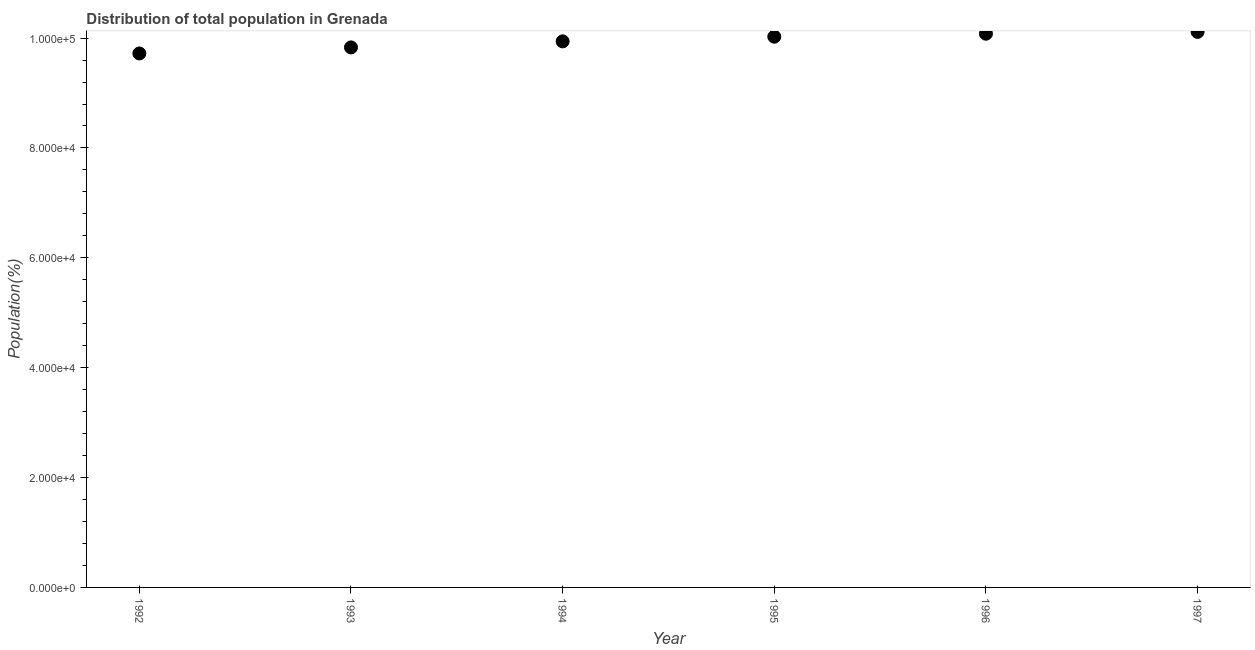What is the population in 1996?
Offer a very short reply. 1.01e+05. Across all years, what is the maximum population?
Your answer should be compact. 1.01e+05. Across all years, what is the minimum population?
Provide a short and direct response. 9.72e+04. In which year was the population minimum?
Keep it short and to the point. 1992. What is the sum of the population?
Provide a short and direct response. 5.97e+05. What is the difference between the population in 1992 and 1996?
Ensure brevity in your answer.  -3595. What is the average population per year?
Provide a succinct answer. 9.95e+04. What is the median population?
Your answer should be very brief. 9.98e+04. Do a majority of the years between 1997 and 1993 (inclusive) have population greater than 36000 %?
Offer a very short reply. Yes. What is the ratio of the population in 1993 to that in 1996?
Provide a succinct answer. 0.98. What is the difference between the highest and the second highest population?
Your response must be concise. 329. Is the sum of the population in 1993 and 1996 greater than the maximum population across all years?
Your answer should be compact. Yes. What is the difference between the highest and the lowest population?
Provide a short and direct response. 3924. Does the population monotonically increase over the years?
Offer a very short reply. Yes. How many dotlines are there?
Your answer should be very brief. 1. Does the graph contain any zero values?
Offer a terse response. No. What is the title of the graph?
Offer a terse response. Distribution of total population in Grenada . What is the label or title of the X-axis?
Make the answer very short. Year. What is the label or title of the Y-axis?
Make the answer very short. Population(%). What is the Population(%) in 1992?
Your answer should be compact. 9.72e+04. What is the Population(%) in 1993?
Offer a terse response. 9.83e+04. What is the Population(%) in 1994?
Offer a very short reply. 9.94e+04. What is the Population(%) in 1995?
Offer a terse response. 1.00e+05. What is the Population(%) in 1996?
Your response must be concise. 1.01e+05. What is the Population(%) in 1997?
Make the answer very short. 1.01e+05. What is the difference between the Population(%) in 1992 and 1993?
Offer a very short reply. -1101. What is the difference between the Population(%) in 1992 and 1994?
Give a very brief answer. -2202. What is the difference between the Population(%) in 1992 and 1995?
Provide a succinct answer. -3052. What is the difference between the Population(%) in 1992 and 1996?
Your answer should be compact. -3595. What is the difference between the Population(%) in 1992 and 1997?
Your response must be concise. -3924. What is the difference between the Population(%) in 1993 and 1994?
Your answer should be very brief. -1101. What is the difference between the Population(%) in 1993 and 1995?
Keep it short and to the point. -1951. What is the difference between the Population(%) in 1993 and 1996?
Your response must be concise. -2494. What is the difference between the Population(%) in 1993 and 1997?
Keep it short and to the point. -2823. What is the difference between the Population(%) in 1994 and 1995?
Your response must be concise. -850. What is the difference between the Population(%) in 1994 and 1996?
Provide a succinct answer. -1393. What is the difference between the Population(%) in 1994 and 1997?
Offer a terse response. -1722. What is the difference between the Population(%) in 1995 and 1996?
Your response must be concise. -543. What is the difference between the Population(%) in 1995 and 1997?
Your answer should be compact. -872. What is the difference between the Population(%) in 1996 and 1997?
Offer a terse response. -329. What is the ratio of the Population(%) in 1992 to that in 1994?
Offer a very short reply. 0.98. What is the ratio of the Population(%) in 1992 to that in 1995?
Provide a succinct answer. 0.97. What is the ratio of the Population(%) in 1992 to that in 1996?
Give a very brief answer. 0.96. What is the ratio of the Population(%) in 1993 to that in 1994?
Provide a short and direct response. 0.99. What is the ratio of the Population(%) in 1993 to that in 1995?
Your answer should be compact. 0.98. What is the ratio of the Population(%) in 1993 to that in 1997?
Offer a terse response. 0.97. What is the ratio of the Population(%) in 1995 to that in 1996?
Make the answer very short. 0.99. What is the ratio of the Population(%) in 1995 to that in 1997?
Give a very brief answer. 0.99. What is the ratio of the Population(%) in 1996 to that in 1997?
Make the answer very short. 1. 